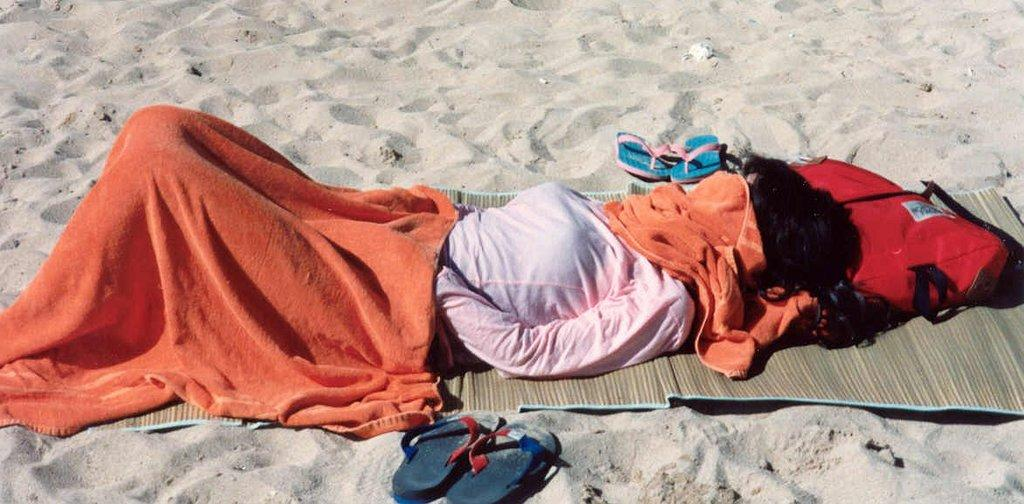Who is present in the image? There is a woman in the image. What is the woman wearing? The woman is wearing a pink dress. What is the woman laying on? The woman is laying on a red bag. Where is the red bag placed? The red bag is placed on the sand. What is placed on the woman? Orange clothes are placed on the woman. What can be seen in the background of the image? There are slippers visible in the background of the image. What type of friction is being generated between the woman and the sand in the image? There is no information about friction between the woman and the sand in the image. The image only shows a woman laying on a red bag placed on the sand. 